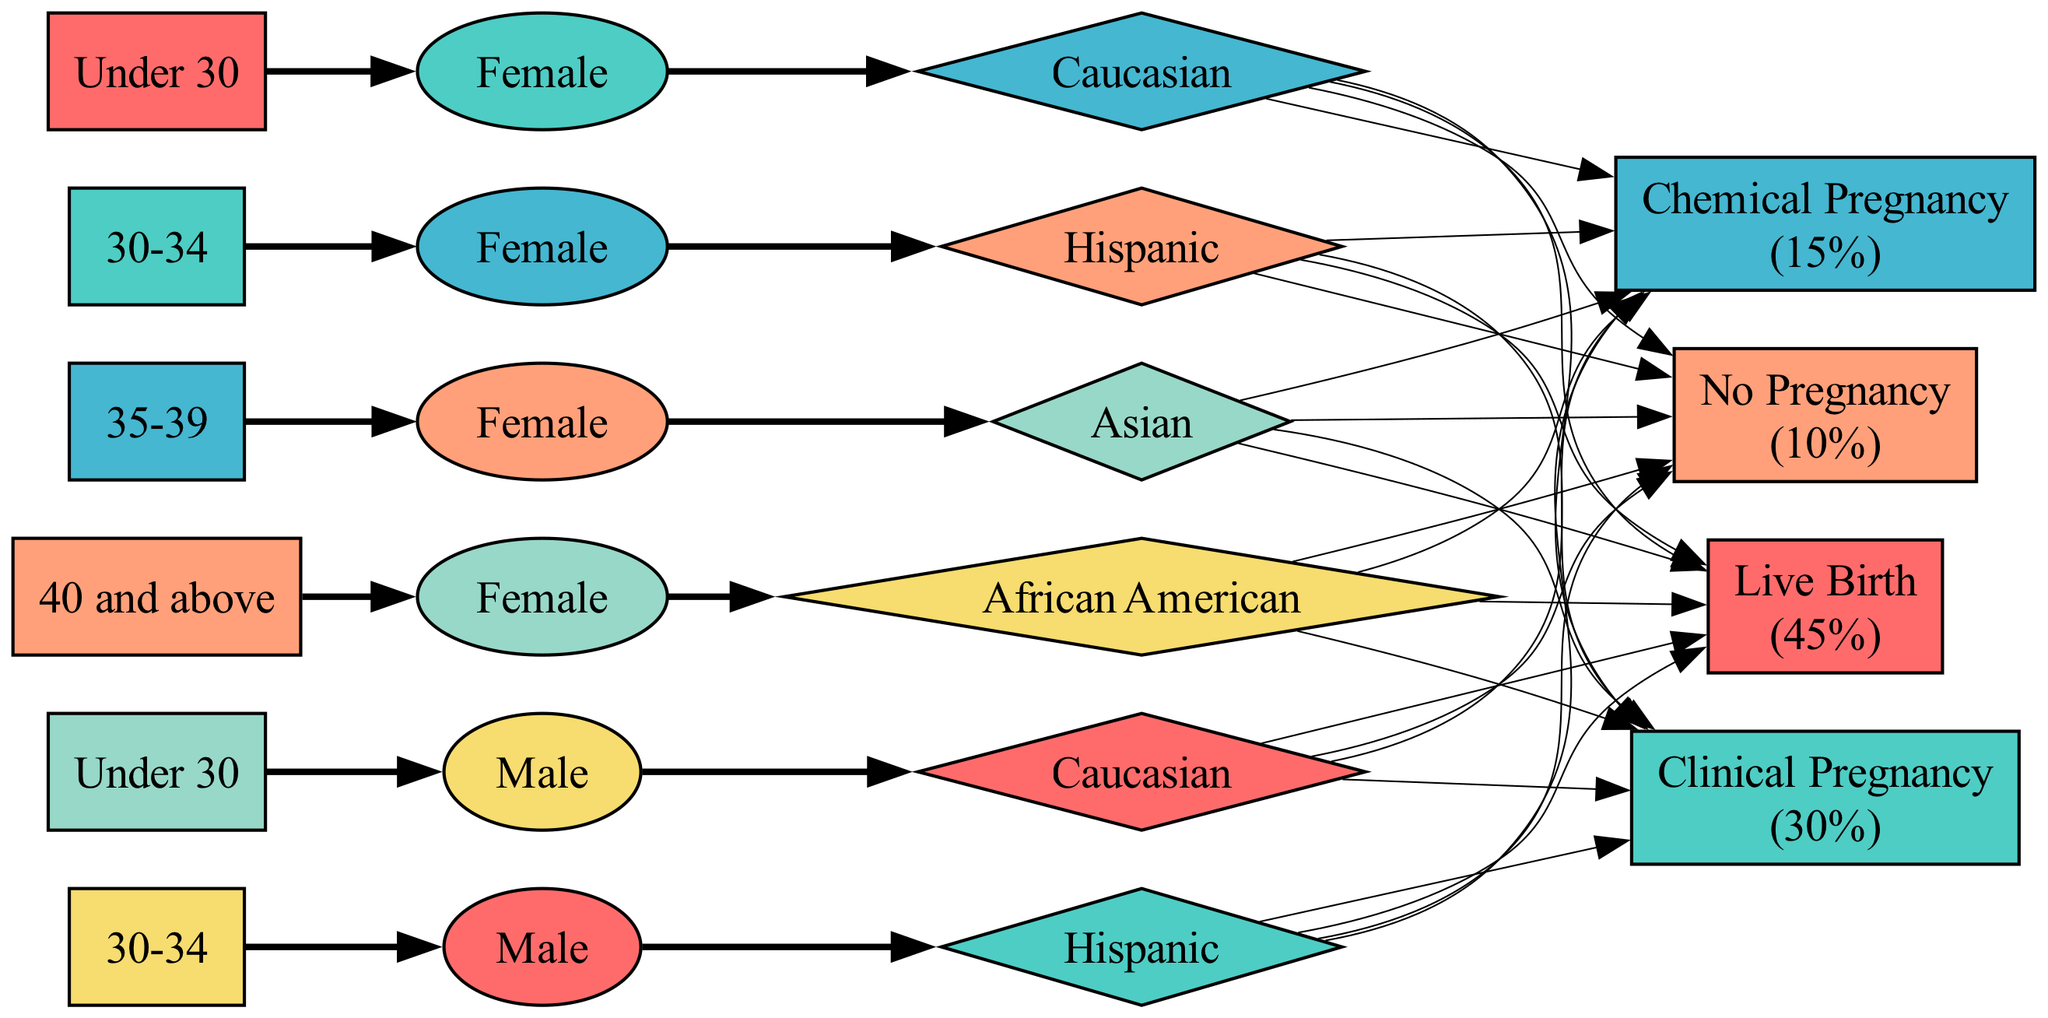What is the age group of the demographic that has the highest treatment outcome rate? By analyzing the treatment outcome rates for each demographic in the diagram, we can determine which age group corresponds to the highest success rate. In this case, we find that the demographic under 30 has a direct connection to the live birth outcome, which has the highest success rate of 45%.
Answer: Under 30 How many treatment outcomes are represented in the diagram? The diagram includes several nodes that represent treatment outcomes. By counting these nodes, we find four distinct treatment outcomes present in the diagram: Live Birth, Clinical Pregnancy, Chemical Pregnancy, and No Pregnancy.
Answer: 4 Which demographic has a direct link to the “No Pregnancy” outcome? To find the demographic linked to the “No Pregnancy” outcome, we trace the edges from each demographic to the treatment outcomes. All demographic nodes lead to the treatment outcomes, but there is no specific demographic linked directly only to "No Pregnancy," as this outcome has edges from all demographics.
Answer: All demographics What treatment outcome has the lowest success rate? By examining each treatment outcome node, we can see the success rates listed alongside them. The treatment outcome labeled "No Pregnancy," specifically states a success rate of 10%, which is the lowest among all outcomes depicted in the diagram.
Answer: No Pregnancy What is the success rate of the “Live Birth” outcome? In the treatment outcomes section of the diagram, the "Live Birth" node clearly displays a success rate of 45%. This node is directly connected to various demographic groups that influence this outcome.
Answer: 45% 